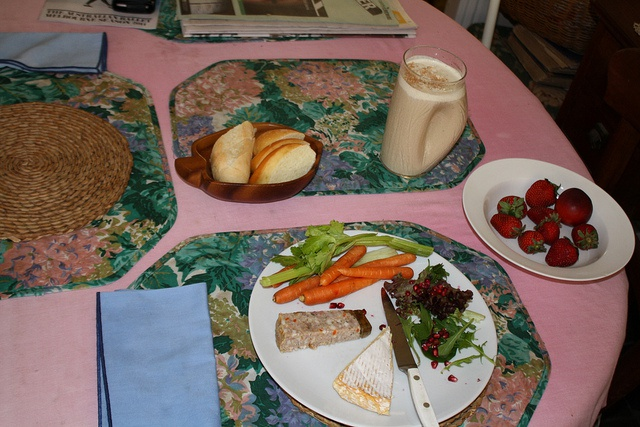Describe the objects in this image and their specific colors. I can see dining table in brown, darkgray, gray, and black tones, bowl in brown, darkgray, maroon, black, and gray tones, bowl in brown, maroon, tan, and black tones, cup in brown, tan, and gray tones, and knife in brown, maroon, lightgray, darkgray, and black tones in this image. 